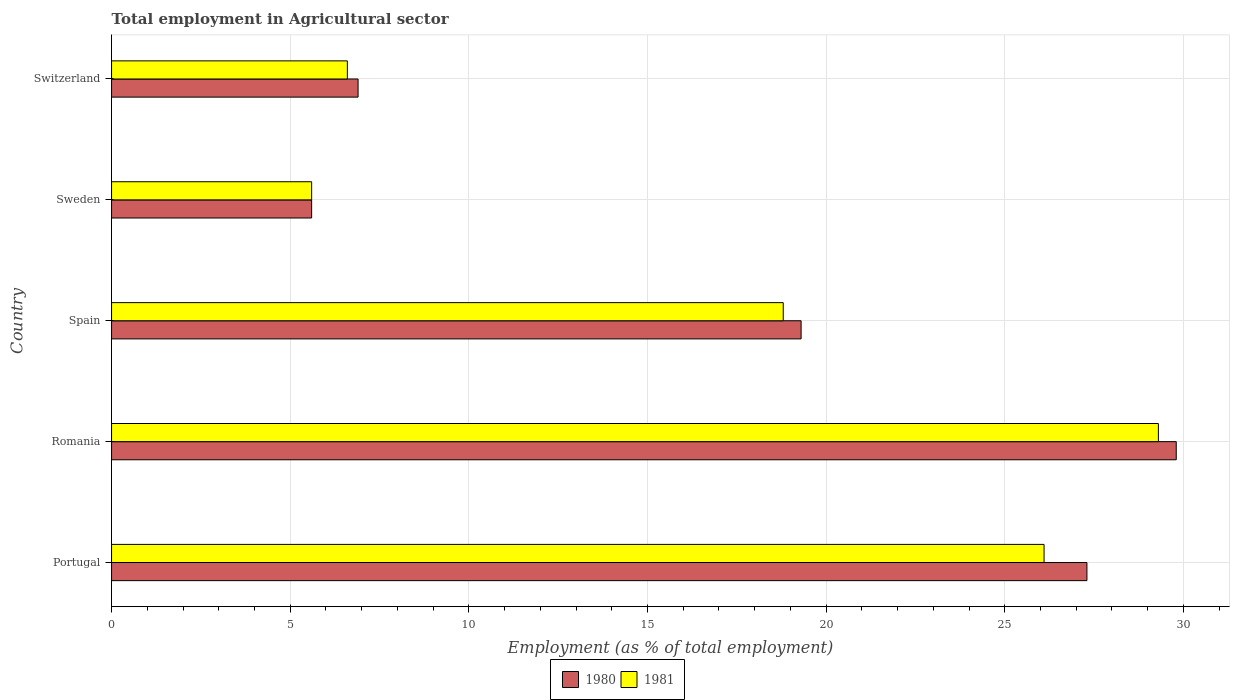How many different coloured bars are there?
Provide a short and direct response. 2. How many groups of bars are there?
Give a very brief answer. 5. How many bars are there on the 5th tick from the top?
Offer a terse response. 2. How many bars are there on the 1st tick from the bottom?
Give a very brief answer. 2. What is the label of the 4th group of bars from the top?
Make the answer very short. Romania. What is the employment in agricultural sector in 1980 in Spain?
Your answer should be very brief. 19.3. Across all countries, what is the maximum employment in agricultural sector in 1981?
Your answer should be very brief. 29.3. Across all countries, what is the minimum employment in agricultural sector in 1981?
Offer a terse response. 5.6. In which country was the employment in agricultural sector in 1981 maximum?
Provide a short and direct response. Romania. What is the total employment in agricultural sector in 1981 in the graph?
Provide a succinct answer. 86.4. What is the difference between the employment in agricultural sector in 1980 in Romania and that in Sweden?
Make the answer very short. 24.2. What is the difference between the employment in agricultural sector in 1980 in Spain and the employment in agricultural sector in 1981 in Sweden?
Ensure brevity in your answer.  13.7. What is the average employment in agricultural sector in 1981 per country?
Provide a succinct answer. 17.28. What is the difference between the employment in agricultural sector in 1981 and employment in agricultural sector in 1980 in Spain?
Offer a very short reply. -0.5. What is the ratio of the employment in agricultural sector in 1981 in Sweden to that in Switzerland?
Keep it short and to the point. 0.85. What is the difference between the highest and the second highest employment in agricultural sector in 1981?
Offer a terse response. 3.2. What is the difference between the highest and the lowest employment in agricultural sector in 1980?
Offer a very short reply. 24.2. In how many countries, is the employment in agricultural sector in 1981 greater than the average employment in agricultural sector in 1981 taken over all countries?
Provide a short and direct response. 3. Is the sum of the employment in agricultural sector in 1980 in Portugal and Switzerland greater than the maximum employment in agricultural sector in 1981 across all countries?
Your answer should be very brief. Yes. What does the 1st bar from the top in Romania represents?
Provide a succinct answer. 1981. How many bars are there?
Make the answer very short. 10. How many countries are there in the graph?
Ensure brevity in your answer.  5. What is the difference between two consecutive major ticks on the X-axis?
Your response must be concise. 5. Are the values on the major ticks of X-axis written in scientific E-notation?
Give a very brief answer. No. How are the legend labels stacked?
Your answer should be compact. Horizontal. What is the title of the graph?
Your answer should be compact. Total employment in Agricultural sector. Does "1977" appear as one of the legend labels in the graph?
Keep it short and to the point. No. What is the label or title of the X-axis?
Your response must be concise. Employment (as % of total employment). What is the label or title of the Y-axis?
Your response must be concise. Country. What is the Employment (as % of total employment) in 1980 in Portugal?
Ensure brevity in your answer.  27.3. What is the Employment (as % of total employment) of 1981 in Portugal?
Your answer should be compact. 26.1. What is the Employment (as % of total employment) of 1980 in Romania?
Your answer should be very brief. 29.8. What is the Employment (as % of total employment) of 1981 in Romania?
Ensure brevity in your answer.  29.3. What is the Employment (as % of total employment) of 1980 in Spain?
Give a very brief answer. 19.3. What is the Employment (as % of total employment) of 1981 in Spain?
Give a very brief answer. 18.8. What is the Employment (as % of total employment) in 1980 in Sweden?
Keep it short and to the point. 5.6. What is the Employment (as % of total employment) in 1981 in Sweden?
Ensure brevity in your answer.  5.6. What is the Employment (as % of total employment) in 1980 in Switzerland?
Your response must be concise. 6.9. What is the Employment (as % of total employment) in 1981 in Switzerland?
Give a very brief answer. 6.6. Across all countries, what is the maximum Employment (as % of total employment) of 1980?
Provide a succinct answer. 29.8. Across all countries, what is the maximum Employment (as % of total employment) in 1981?
Give a very brief answer. 29.3. Across all countries, what is the minimum Employment (as % of total employment) of 1980?
Offer a terse response. 5.6. Across all countries, what is the minimum Employment (as % of total employment) in 1981?
Keep it short and to the point. 5.6. What is the total Employment (as % of total employment) of 1980 in the graph?
Keep it short and to the point. 88.9. What is the total Employment (as % of total employment) of 1981 in the graph?
Make the answer very short. 86.4. What is the difference between the Employment (as % of total employment) in 1980 in Portugal and that in Romania?
Make the answer very short. -2.5. What is the difference between the Employment (as % of total employment) in 1980 in Portugal and that in Spain?
Your response must be concise. 8. What is the difference between the Employment (as % of total employment) of 1981 in Portugal and that in Spain?
Your answer should be compact. 7.3. What is the difference between the Employment (as % of total employment) of 1980 in Portugal and that in Sweden?
Ensure brevity in your answer.  21.7. What is the difference between the Employment (as % of total employment) in 1981 in Portugal and that in Sweden?
Ensure brevity in your answer.  20.5. What is the difference between the Employment (as % of total employment) in 1980 in Portugal and that in Switzerland?
Offer a terse response. 20.4. What is the difference between the Employment (as % of total employment) in 1981 in Portugal and that in Switzerland?
Offer a very short reply. 19.5. What is the difference between the Employment (as % of total employment) of 1980 in Romania and that in Spain?
Your answer should be compact. 10.5. What is the difference between the Employment (as % of total employment) of 1980 in Romania and that in Sweden?
Make the answer very short. 24.2. What is the difference between the Employment (as % of total employment) of 1981 in Romania and that in Sweden?
Ensure brevity in your answer.  23.7. What is the difference between the Employment (as % of total employment) of 1980 in Romania and that in Switzerland?
Your response must be concise. 22.9. What is the difference between the Employment (as % of total employment) in 1981 in Romania and that in Switzerland?
Give a very brief answer. 22.7. What is the difference between the Employment (as % of total employment) of 1981 in Spain and that in Sweden?
Offer a terse response. 13.2. What is the difference between the Employment (as % of total employment) in 1980 in Spain and that in Switzerland?
Offer a very short reply. 12.4. What is the difference between the Employment (as % of total employment) in 1981 in Spain and that in Switzerland?
Provide a short and direct response. 12.2. What is the difference between the Employment (as % of total employment) of 1980 in Portugal and the Employment (as % of total employment) of 1981 in Sweden?
Keep it short and to the point. 21.7. What is the difference between the Employment (as % of total employment) of 1980 in Portugal and the Employment (as % of total employment) of 1981 in Switzerland?
Offer a very short reply. 20.7. What is the difference between the Employment (as % of total employment) of 1980 in Romania and the Employment (as % of total employment) of 1981 in Spain?
Keep it short and to the point. 11. What is the difference between the Employment (as % of total employment) in 1980 in Romania and the Employment (as % of total employment) in 1981 in Sweden?
Provide a short and direct response. 24.2. What is the difference between the Employment (as % of total employment) of 1980 in Romania and the Employment (as % of total employment) of 1981 in Switzerland?
Provide a succinct answer. 23.2. What is the difference between the Employment (as % of total employment) in 1980 in Spain and the Employment (as % of total employment) in 1981 in Switzerland?
Give a very brief answer. 12.7. What is the average Employment (as % of total employment) of 1980 per country?
Your answer should be very brief. 17.78. What is the average Employment (as % of total employment) of 1981 per country?
Offer a terse response. 17.28. What is the difference between the Employment (as % of total employment) in 1980 and Employment (as % of total employment) in 1981 in Portugal?
Make the answer very short. 1.2. What is the difference between the Employment (as % of total employment) of 1980 and Employment (as % of total employment) of 1981 in Romania?
Give a very brief answer. 0.5. What is the difference between the Employment (as % of total employment) of 1980 and Employment (as % of total employment) of 1981 in Switzerland?
Ensure brevity in your answer.  0.3. What is the ratio of the Employment (as % of total employment) of 1980 in Portugal to that in Romania?
Ensure brevity in your answer.  0.92. What is the ratio of the Employment (as % of total employment) in 1981 in Portugal to that in Romania?
Offer a very short reply. 0.89. What is the ratio of the Employment (as % of total employment) in 1980 in Portugal to that in Spain?
Give a very brief answer. 1.41. What is the ratio of the Employment (as % of total employment) in 1981 in Portugal to that in Spain?
Offer a very short reply. 1.39. What is the ratio of the Employment (as % of total employment) of 1980 in Portugal to that in Sweden?
Ensure brevity in your answer.  4.88. What is the ratio of the Employment (as % of total employment) in 1981 in Portugal to that in Sweden?
Keep it short and to the point. 4.66. What is the ratio of the Employment (as % of total employment) in 1980 in Portugal to that in Switzerland?
Offer a very short reply. 3.96. What is the ratio of the Employment (as % of total employment) in 1981 in Portugal to that in Switzerland?
Give a very brief answer. 3.95. What is the ratio of the Employment (as % of total employment) of 1980 in Romania to that in Spain?
Provide a succinct answer. 1.54. What is the ratio of the Employment (as % of total employment) in 1981 in Romania to that in Spain?
Your response must be concise. 1.56. What is the ratio of the Employment (as % of total employment) in 1980 in Romania to that in Sweden?
Provide a short and direct response. 5.32. What is the ratio of the Employment (as % of total employment) of 1981 in Romania to that in Sweden?
Offer a terse response. 5.23. What is the ratio of the Employment (as % of total employment) in 1980 in Romania to that in Switzerland?
Make the answer very short. 4.32. What is the ratio of the Employment (as % of total employment) of 1981 in Romania to that in Switzerland?
Give a very brief answer. 4.44. What is the ratio of the Employment (as % of total employment) in 1980 in Spain to that in Sweden?
Provide a short and direct response. 3.45. What is the ratio of the Employment (as % of total employment) of 1981 in Spain to that in Sweden?
Your answer should be compact. 3.36. What is the ratio of the Employment (as % of total employment) of 1980 in Spain to that in Switzerland?
Your response must be concise. 2.8. What is the ratio of the Employment (as % of total employment) in 1981 in Spain to that in Switzerland?
Give a very brief answer. 2.85. What is the ratio of the Employment (as % of total employment) of 1980 in Sweden to that in Switzerland?
Your answer should be compact. 0.81. What is the ratio of the Employment (as % of total employment) in 1981 in Sweden to that in Switzerland?
Keep it short and to the point. 0.85. What is the difference between the highest and the second highest Employment (as % of total employment) of 1981?
Make the answer very short. 3.2. What is the difference between the highest and the lowest Employment (as % of total employment) in 1980?
Offer a terse response. 24.2. What is the difference between the highest and the lowest Employment (as % of total employment) of 1981?
Keep it short and to the point. 23.7. 